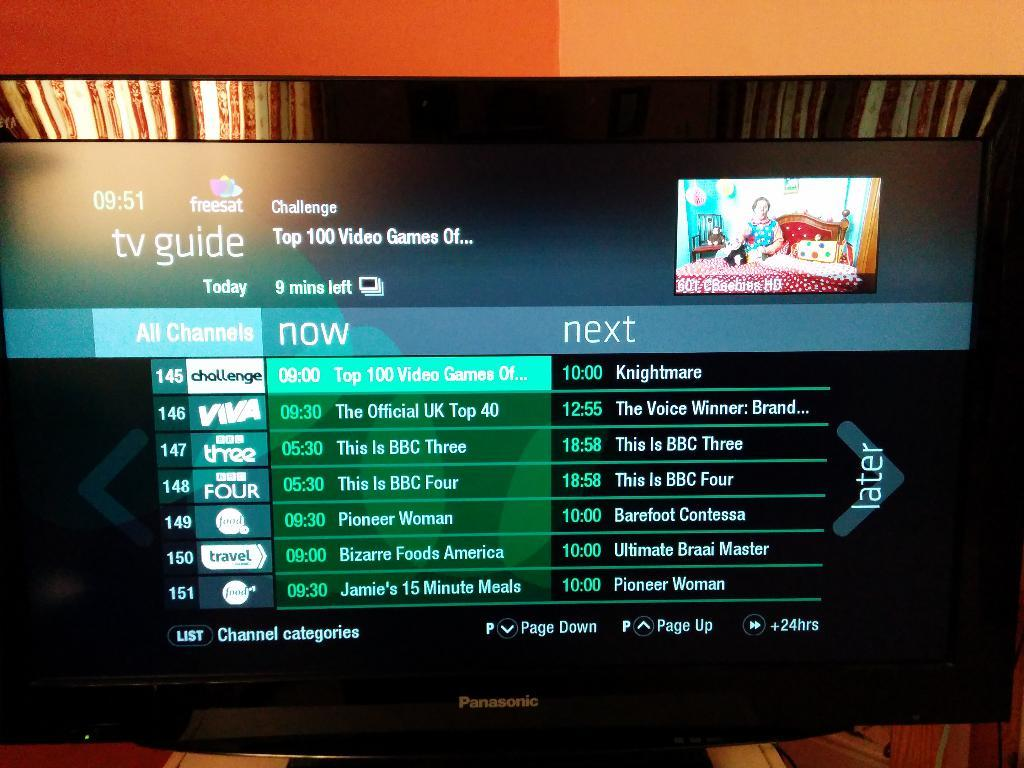<image>
Write a terse but informative summary of the picture. The TV guide channel on a television shows the shows coming up on channel 145 through channel 151. 